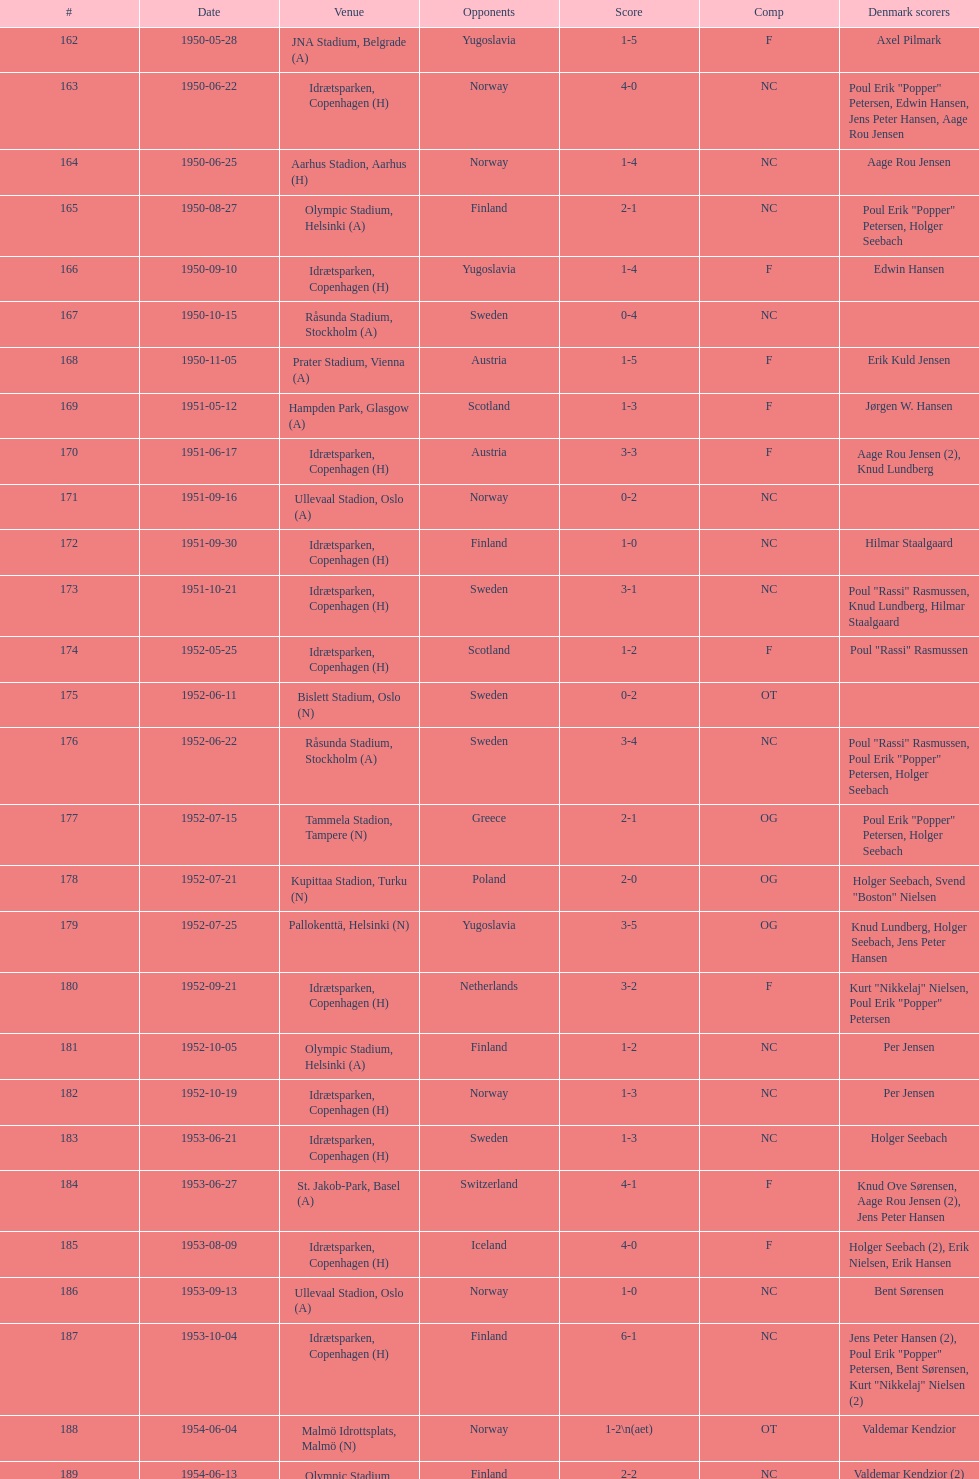What are the number of times nc appears under the comp column? 32. 